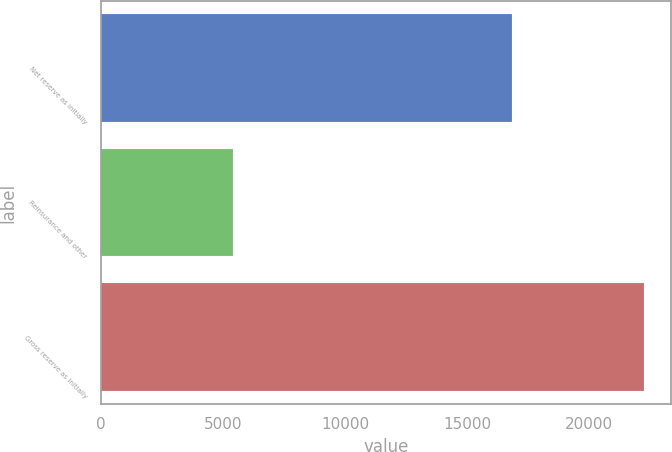<chart> <loc_0><loc_0><loc_500><loc_500><bar_chart><fcel>Net reserve as initially<fcel>Reinsurance and other<fcel>Gross reserve as initially<nl><fcel>16863<fcel>5403<fcel>22266<nl></chart> 